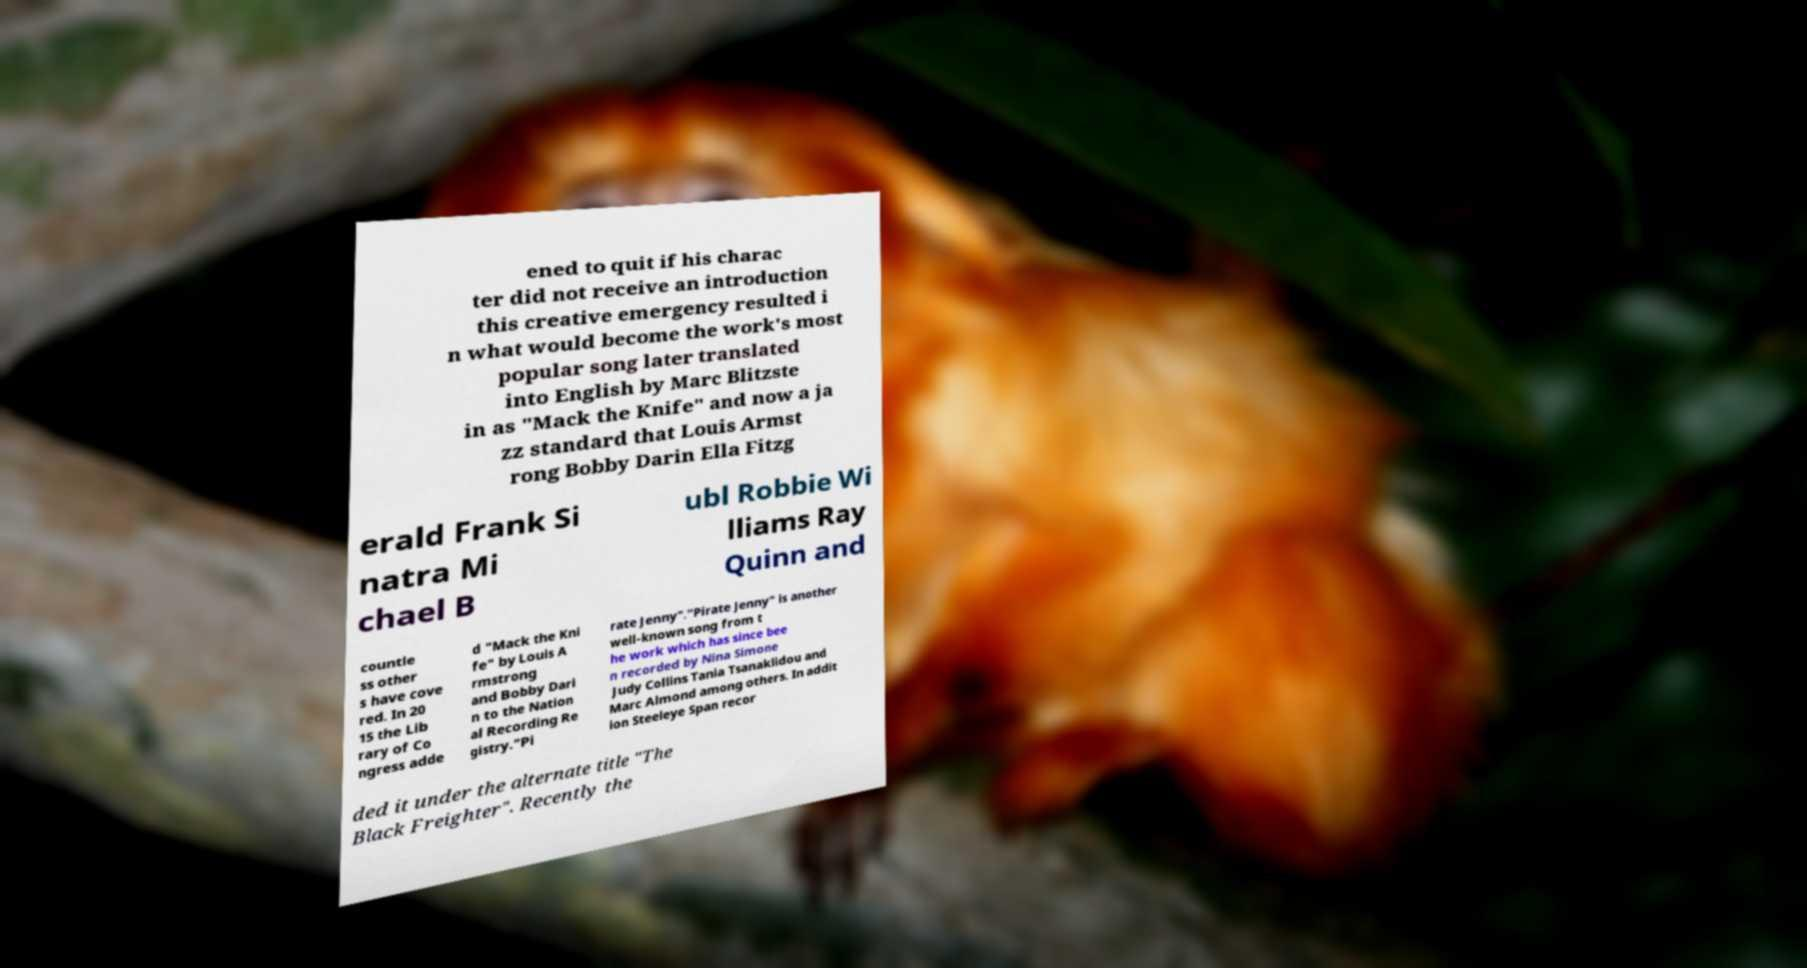There's text embedded in this image that I need extracted. Can you transcribe it verbatim? ened to quit if his charac ter did not receive an introduction this creative emergency resulted i n what would become the work's most popular song later translated into English by Marc Blitzste in as "Mack the Knife" and now a ja zz standard that Louis Armst rong Bobby Darin Ella Fitzg erald Frank Si natra Mi chael B ubl Robbie Wi lliams Ray Quinn and countle ss other s have cove red. In 20 15 the Lib rary of Co ngress adde d "Mack the Kni fe" by Louis A rmstrong and Bobby Dari n to the Nation al Recording Re gistry."Pi rate Jenny"."Pirate Jenny" is another well-known song from t he work which has since bee n recorded by Nina Simone Judy Collins Tania Tsanaklidou and Marc Almond among others. In addit ion Steeleye Span recor ded it under the alternate title "The Black Freighter". Recently the 